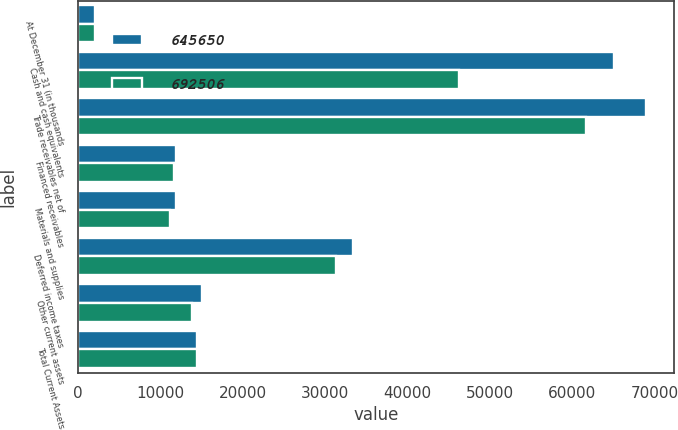Convert chart. <chart><loc_0><loc_0><loc_500><loc_500><stacked_bar_chart><ecel><fcel>At December 31 (in thousands<fcel>Cash and cash equivalents<fcel>Trade receivables net of<fcel>Financed receivables<fcel>Materials and supplies<fcel>Deferred income taxes<fcel>Other current assets<fcel>Total Current Assets<nl><fcel>645650<fcel>2012<fcel>65082<fcel>68920<fcel>11823<fcel>11847<fcel>33338<fcel>14982<fcel>14393<nl><fcel>692506<fcel>2011<fcel>46275<fcel>61687<fcel>11659<fcel>11125<fcel>31272<fcel>13804<fcel>14393<nl></chart> 